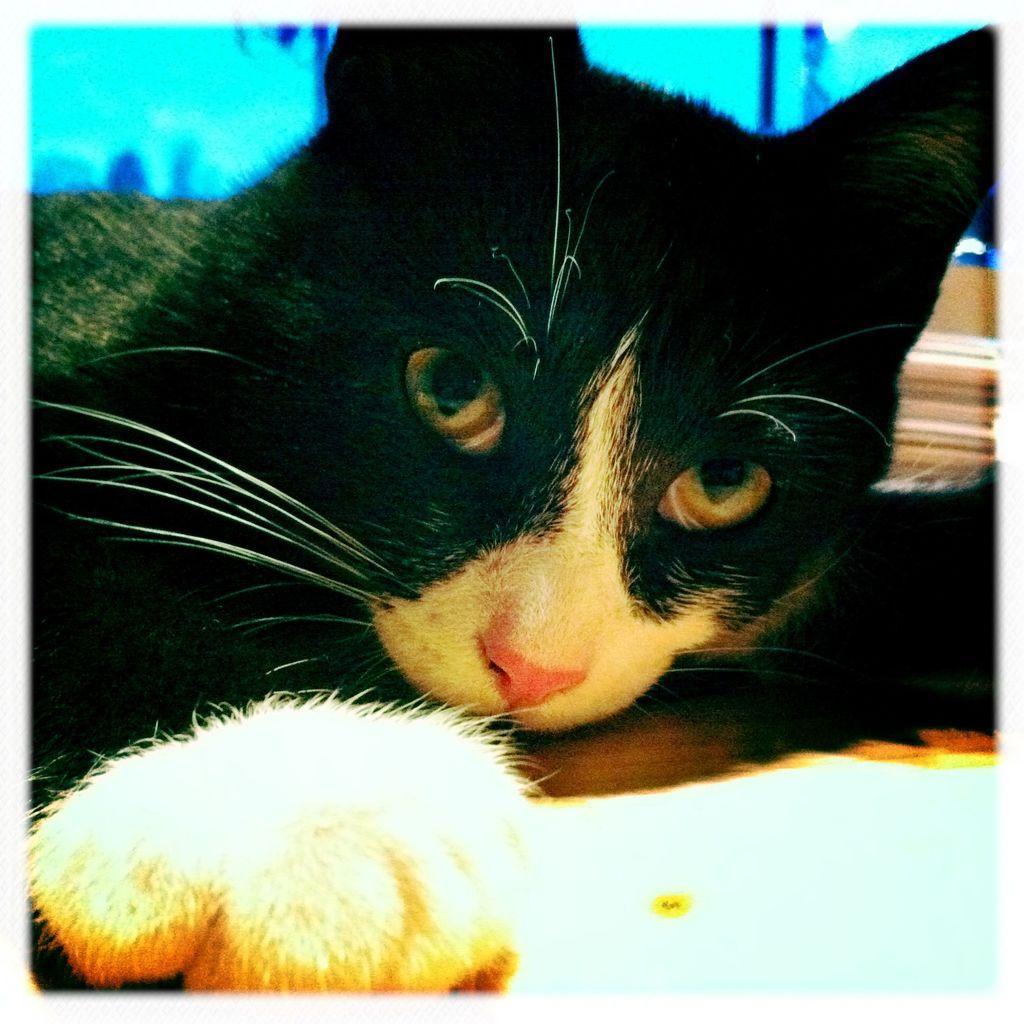Describe this image in one or two sentences. In this picture I can see a cat, and in the background there are some objects. 